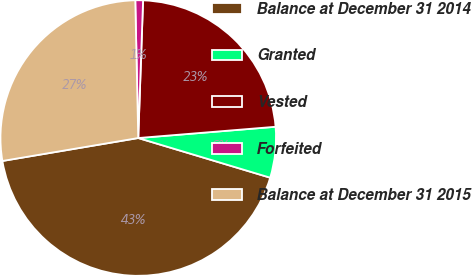<chart> <loc_0><loc_0><loc_500><loc_500><pie_chart><fcel>Balance at December 31 2014<fcel>Granted<fcel>Vested<fcel>Forfeited<fcel>Balance at December 31 2015<nl><fcel>42.69%<fcel>5.95%<fcel>23.14%<fcel>0.9%<fcel>27.32%<nl></chart> 